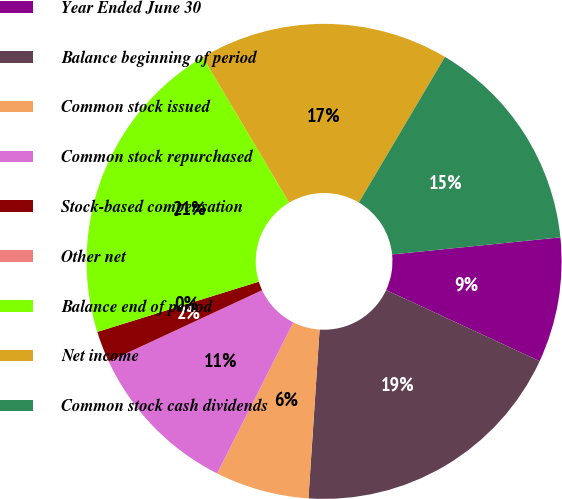Convert chart. <chart><loc_0><loc_0><loc_500><loc_500><pie_chart><fcel>Year Ended June 30<fcel>Balance beginning of period<fcel>Common stock issued<fcel>Common stock repurchased<fcel>Stock-based compensation<fcel>Other net<fcel>Balance end of period<fcel>Net income<fcel>Common stock cash dividends<nl><fcel>8.51%<fcel>19.15%<fcel>6.38%<fcel>10.64%<fcel>2.13%<fcel>0.0%<fcel>21.27%<fcel>17.02%<fcel>14.89%<nl></chart> 